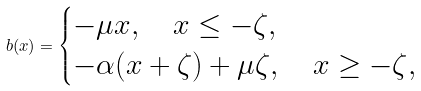Convert formula to latex. <formula><loc_0><loc_0><loc_500><loc_500>b ( x ) = \begin{cases} - \mu x , \quad x \leq - \zeta , \\ - \alpha ( x + \zeta ) + \mu \zeta , \quad x \geq - \zeta , \end{cases}</formula> 